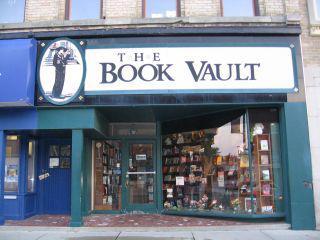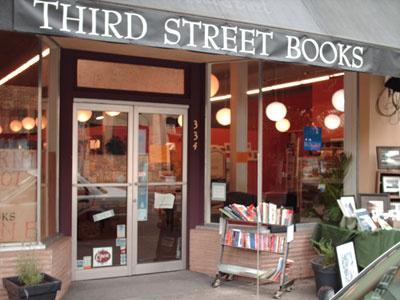The first image is the image on the left, the second image is the image on the right. Analyze the images presented: Is the assertion "The bookstore sign has white lettering on a green background." valid? Answer yes or no. No. The first image is the image on the left, the second image is the image on the right. Given the left and right images, does the statement "A bookstore exterior has the store name on an awning over a double door and has a display stand of books outside the doors." hold true? Answer yes or no. Yes. 